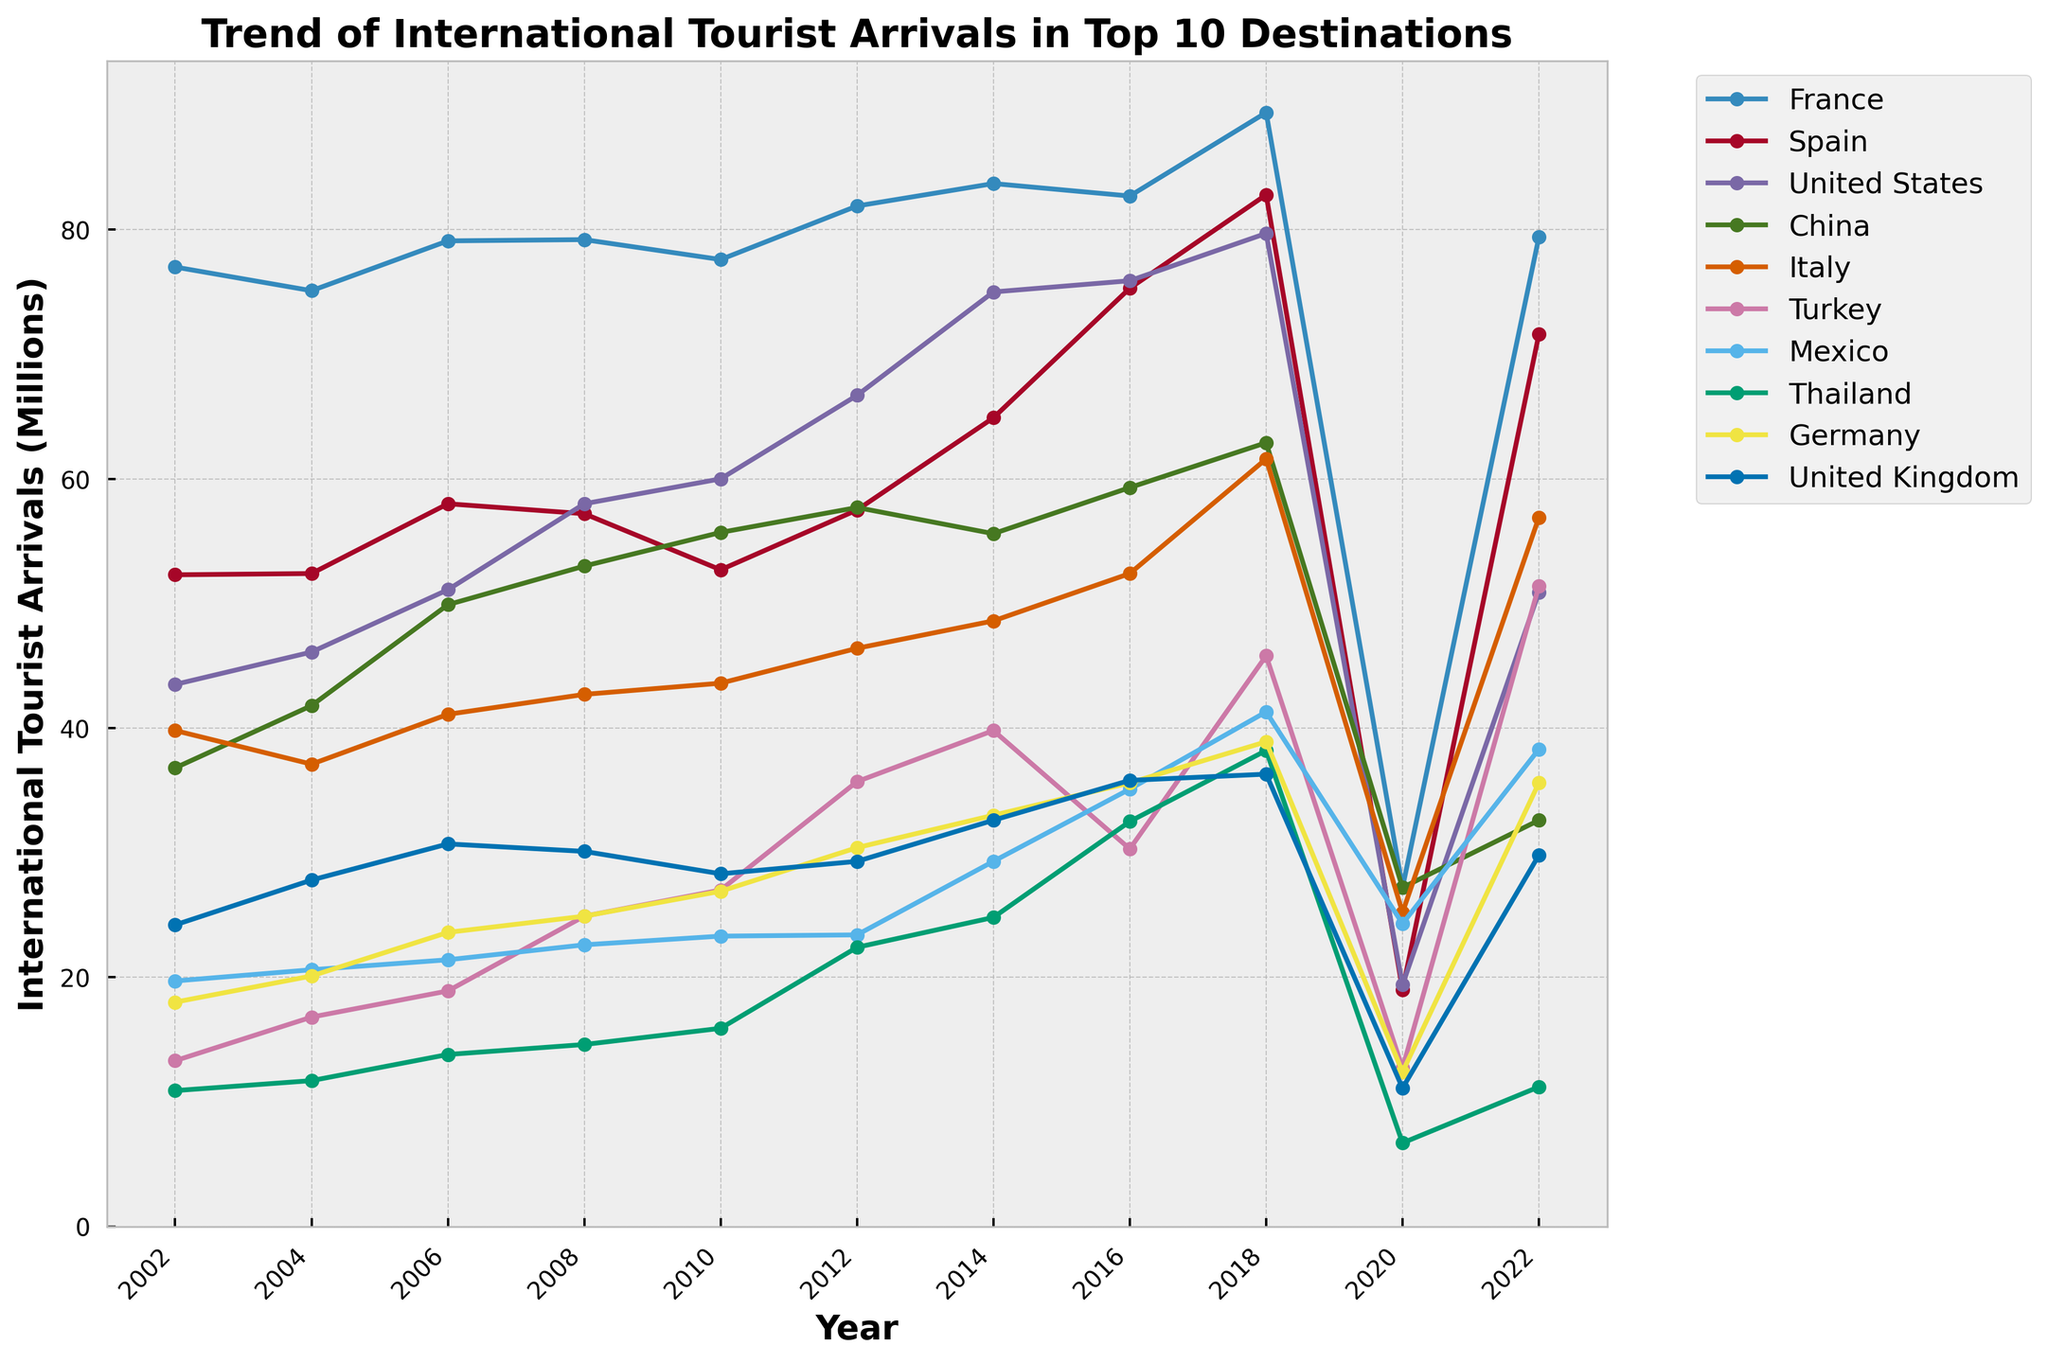what was the peak year for France's tourist arrivals? Look at the plot for France and identify the highest point. The peak year is the year corresponding to this highest point. The highest point on France's line is at 2018.
Answer: 2018 Among the top 10 destinations, which country had the lowest tourist arrivals in 2020? Compare the heights of all the lines for each country at the year 2020. The country with the shortest bar corresponds to the lowest tourist arrivals. Thailand had the lowest tourist arrivals in 2020.
Answer: Thailand How much did tourist arrivals in Italy increase from 2014 to 2018? Check Italy's line and read the values at 2014 and 2018. Subtract the value at 2014 from the value at 2018. Italy had 48.6 million arrivals in 2014 and 61.6 million in 2018. The increase is 61.6 - 48.6 = 13 million.
Answer: 13 million Which two countries had the closest tourist arrival numbers in 2022? Compare the endpoints of the lines for 2022 for all countries and identify the two lines that are closest in height. China and Germany are the closest, with arrivals of 32.6 million and 35.6 million respectively.
Answer: China and Germany Compare the trend of tourist arrivals in Turkey and Mexico from 2002 to 2022. Observe the shapes of the lines representing Turkey and Mexico from 2002 to 2022, noting periods of increase and decrease. Turkey shows substantial growth with some fluctuations, peaking around 2019, while Mexico shows a steady increase with a significant drop in 2020 but better recovery by 2022.
Answer: Turkey shows more fluctuations and higher overall growth, Mexico is steadier When did the United States have its sharpest increase in tourist arrivals? Look at the plot for the United States and identify the period where the line's slope is steepest upwards. The sharpest rise occurs from 2006 to 2008.
Answer: 2006-2008 What was the average number of tourist arrivals in France over the 20-year period? Sum all the data points for France and divide by the number of years. Sum for France is 792.3, divide by 11 (number of data points from 2002 to 2022). 792.3/11 gives approximately 72.0 million.
Answer: 72.0 million Did any country in the top 10 have a decreasing trend over the 20 years? Visually inspect the lines for all countries from 2002 to 2022 to see if any line generally slopes downward. The United Kingdom shows a decrease in overall tourist arrivals when comparing their data from start to end.
Answer: United Kingdom How did tourist arrivals in Thailand change from 2002 to 2018? Look at the plot for Thailand and compare the points at 2002 and 2018. Begin at 10.9 million in 2002 and rise to 38.2 million in 2018. The change is 38.2 - 10.9 = 27.3 million increase.
Answer: 27.3 million increase Which country experienced the most significant drop in tourist arrivals between 2018 and 2020? Compare the heights of the lines for all countries between 2018 and 2020, finding the largest difference. Spain experienced the most significant drop, from 82.8 million in 2018 to 19.0 million in 2020.
Answer: Spain 